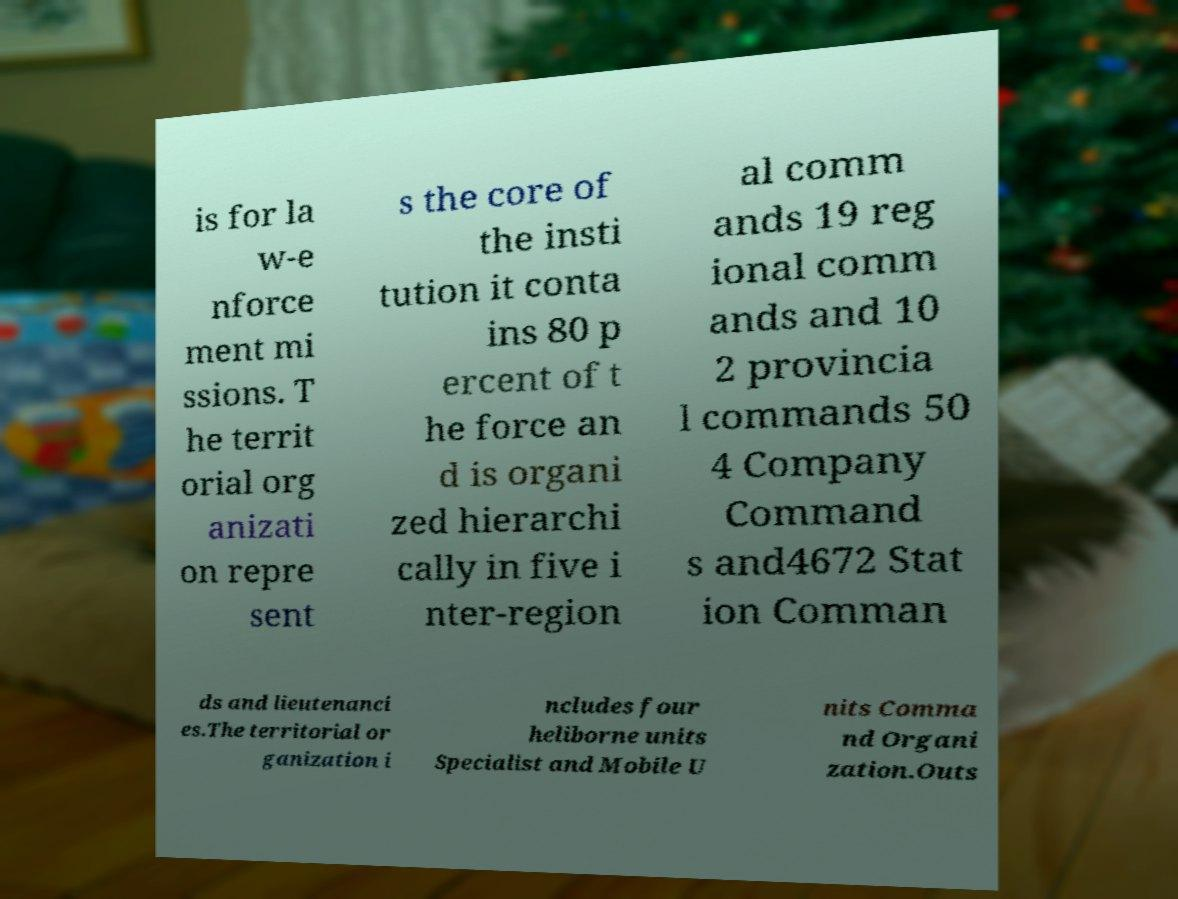Please identify and transcribe the text found in this image. is for la w-e nforce ment mi ssions. T he territ orial org anizati on repre sent s the core of the insti tution it conta ins 80 p ercent of t he force an d is organi zed hierarchi cally in five i nter-region al comm ands 19 reg ional comm ands and 10 2 provincia l commands 50 4 Company Command s and4672 Stat ion Comman ds and lieutenanci es.The territorial or ganization i ncludes four heliborne units Specialist and Mobile U nits Comma nd Organi zation.Outs 